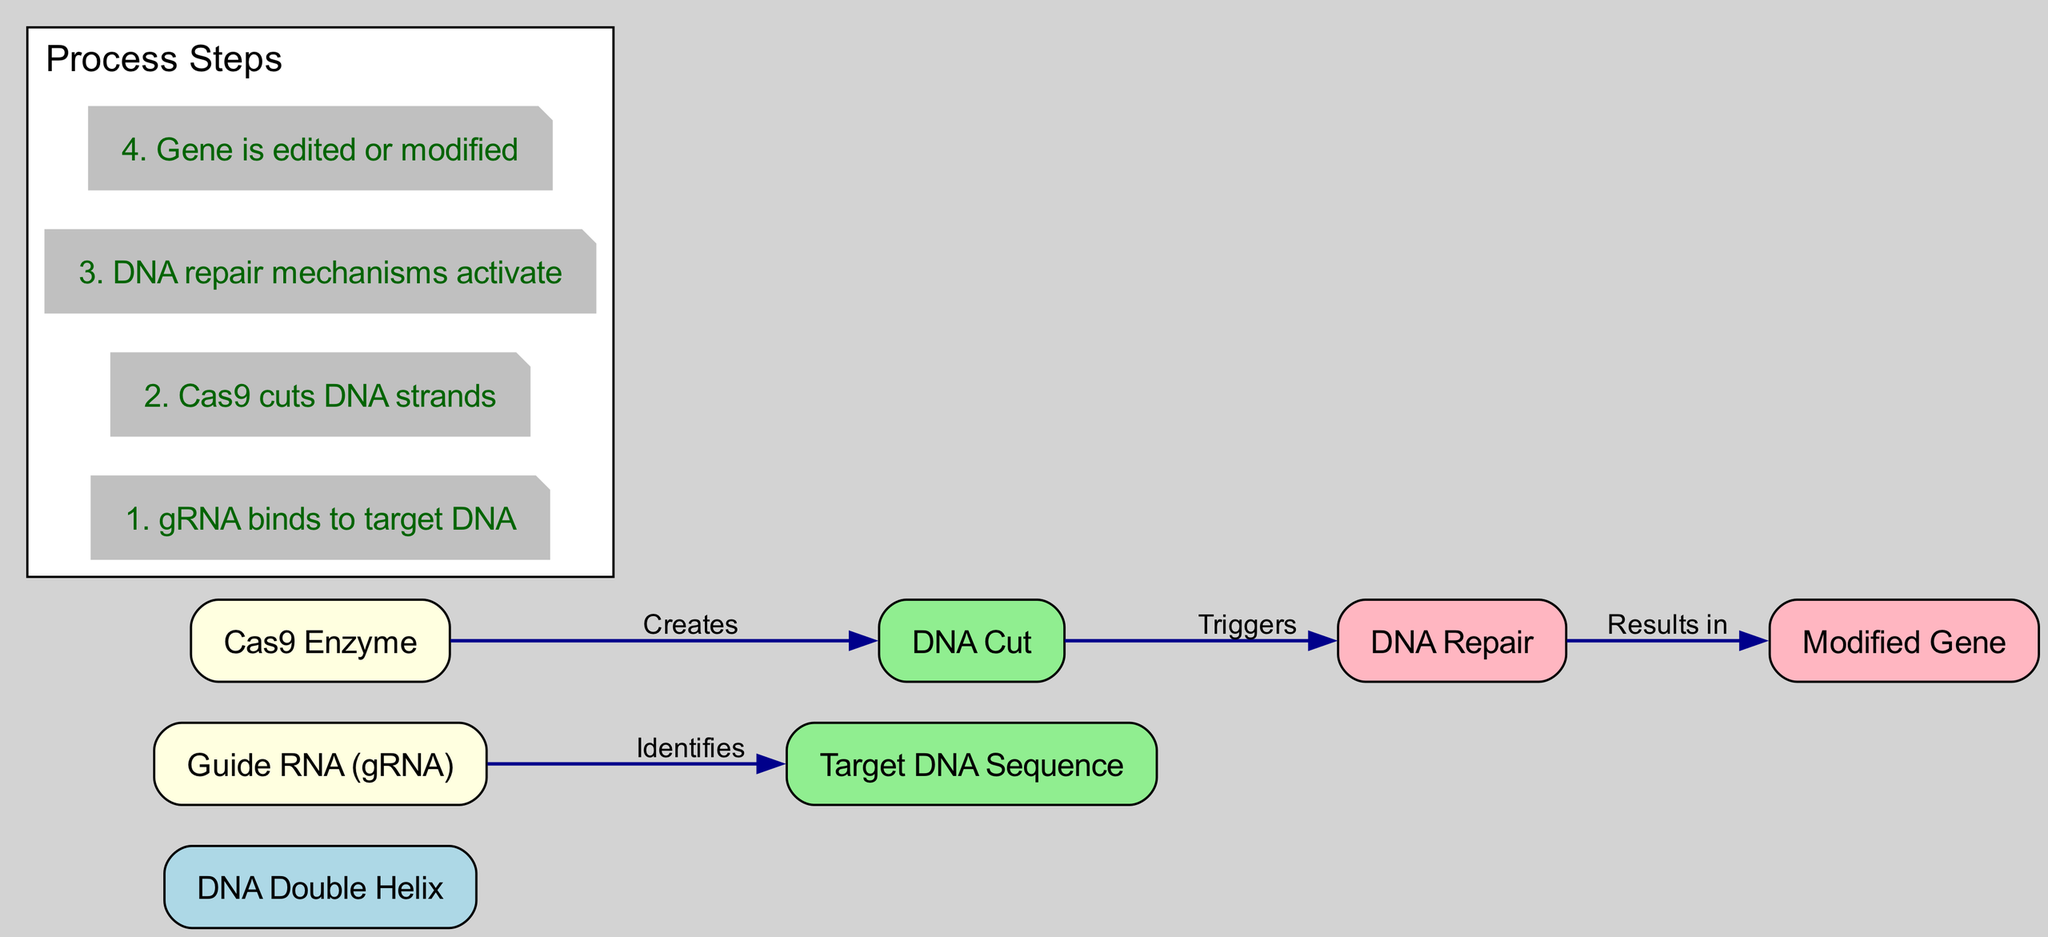What is the first step in the CRISPR-Cas9 process? The first step involves the binding of the guide RNA (gRNA) to the target DNA. This is specifically highlighted in the annotation labeled "1" in the diagram.
Answer: gRNA binds to target DNA How many nodes are present in the diagram? The diagram shows a total of seven nodes, which are labeled from "DNA Double Helix" to "Modified Gene." Each represents a distinct component in the gene editing process.
Answer: 7 Which enzyme is responsible for cutting the DNA strands? According to the diagram, the Cas9 enzyme is indicated as the entity that performs this function, as seen in the edge labeled "Creates" connecting Cas9 to the "DNA Cut."
Answer: Cas9 Enzyme What triggers the DNA repair mechanisms? The diagram shows that the action of cutting the DNA strands leads to the activation of DNA repair mechanisms, highlighted in the edge labeled "Triggers" from "DNA Cut" to "DNA Repair."
Answer: DNA Cut What is the final result of the gene editing process? The final outcome, as per the diagram, is the creation of a modified gene, which can be traced back through the annotations and edges leading from "DNA Repair" to "Modified Gene."
Answer: Modified Gene How does the guide RNA identify the target DNA sequence? The guide RNA identifies the target DNA sequence by specifically binding to it, which is explicitly stated in the relationship labeled "Identifies" from gRNA to the target DNA.
Answer: Identifies What process follows after Cas9 cuts the DNA? After the Cas9 enzyme performs the cut on the DNA, the next process that follows is the activation of DNA repair mechanisms, as shown in the flow from "DNA Cut" to "DNA Repair."
Answer: DNA Repair Which step results in the edited gene? The step that results in the edited gene is the final action led by the DNA repair mechanisms as indicated in the relationship from "DNA Repair" to "Modified Gene."
Answer: Gene is edited or modified 